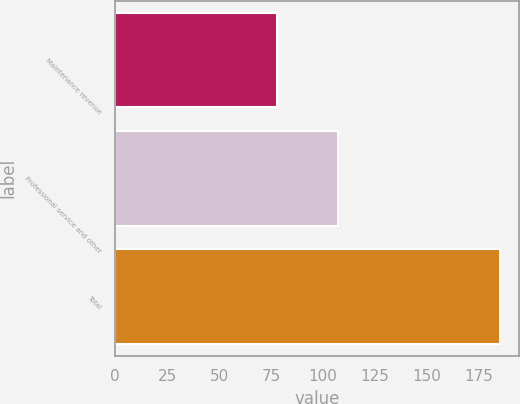Convert chart. <chart><loc_0><loc_0><loc_500><loc_500><bar_chart><fcel>Maintenance revenue<fcel>Professional service and other<fcel>Total<nl><fcel>77.6<fcel>107.2<fcel>184.8<nl></chart> 